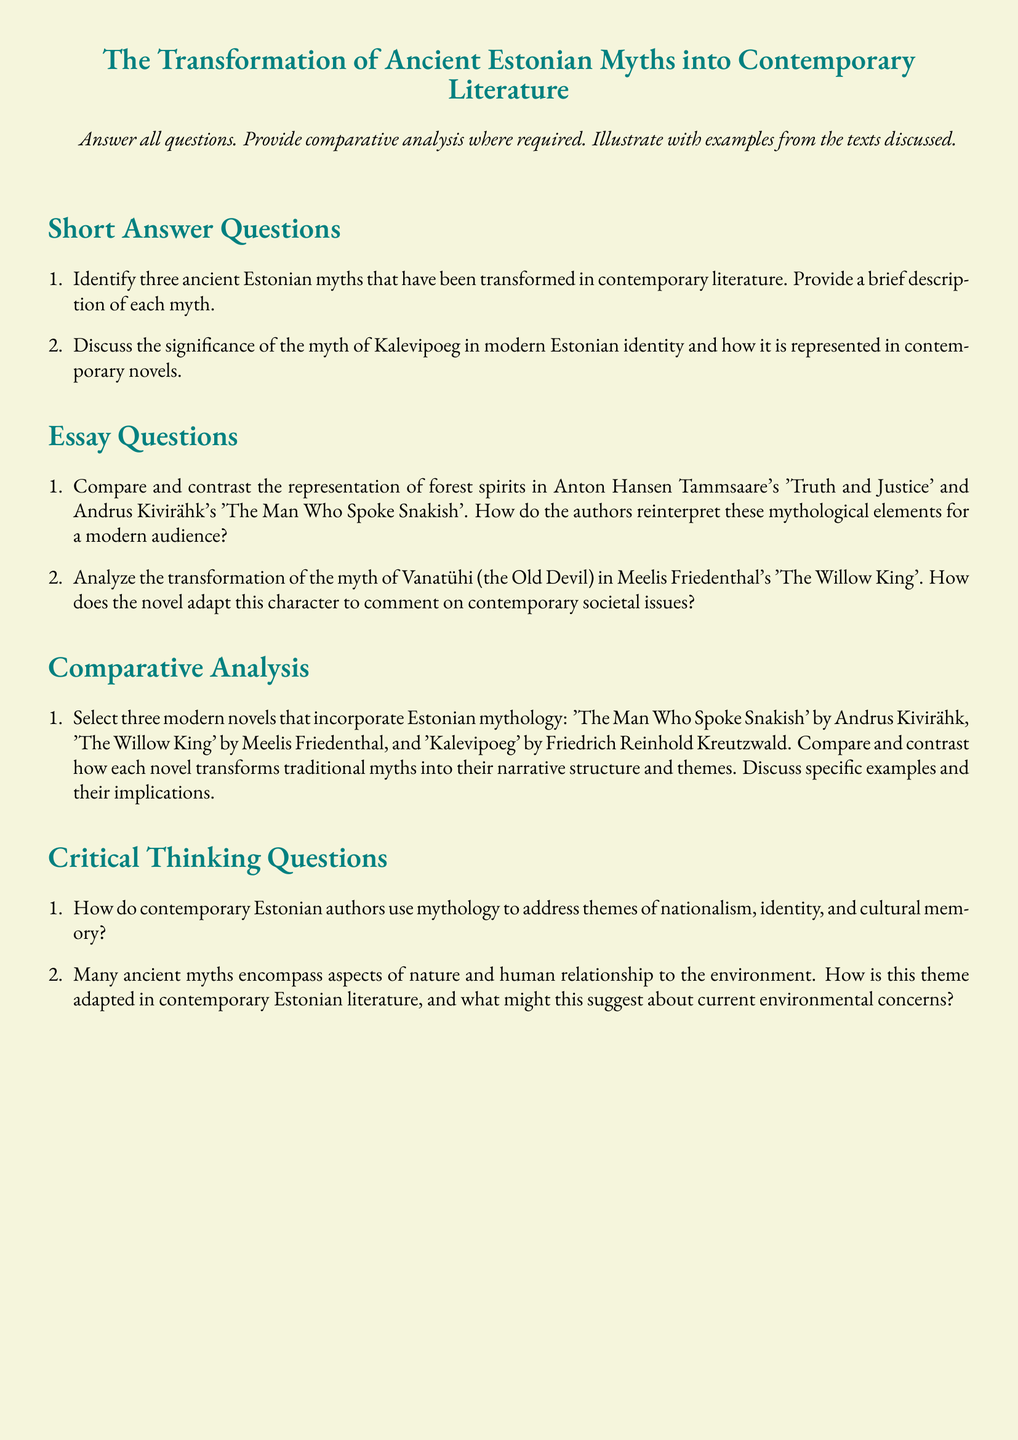what is the title of the document? The title of the document is presented prominently at the center of the title section.
Answer: The Transformation of Ancient Estonian Myths into Contemporary Literature how many short answer questions are there? The document outlines two sections of questions: short answer and essay questions, the short answer section contains two specific questions.
Answer: 2 which author is associated with the novel 'Truth and Justice'? The document mentions this author in the context of a comparison of forest spirits in his work.
Answer: Anton Hansen Tammsaare what is the name of the character adapted from the myth of Vanatühi? The document indicates that this character is central to the analysis in one of the essay questions.
Answer: The Old Devil which three modern novels are discussed in the comparative analysis section? The titles of the novels are explicitly listed in the comparative analysis directive of the document.
Answer: The Man Who Spoke Snakish, The Willow King, Kalevipoeg how many essay questions are present in the document? The document specifically enumerates the types of questions and the count of essay questions indicated here.
Answer: 2 what color theme is used for the document's background? The background color is explicitly described in the setup of the document.
Answer: beige which myth's significance in modern Estonian identity is mentioned in the short answer section? The document refers to an important myth, highlighting its cultural relevance and how it emerges in contemporary works.
Answer: Kalevipoeg how many critical thinking questions are listed in the document? The document includes a section with a specific count of critical thinking questions listed for response.
Answer: 2 